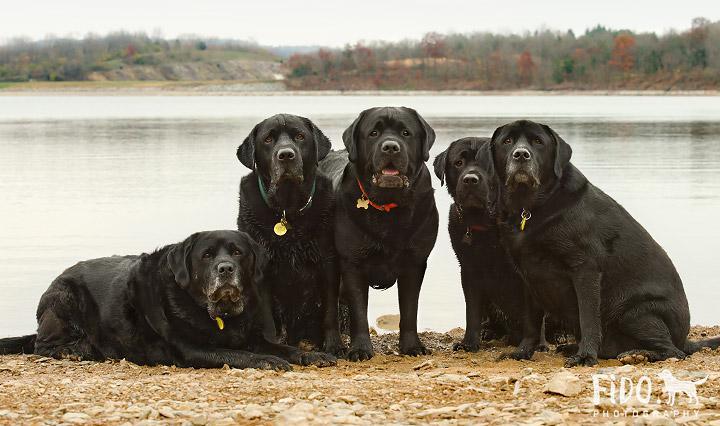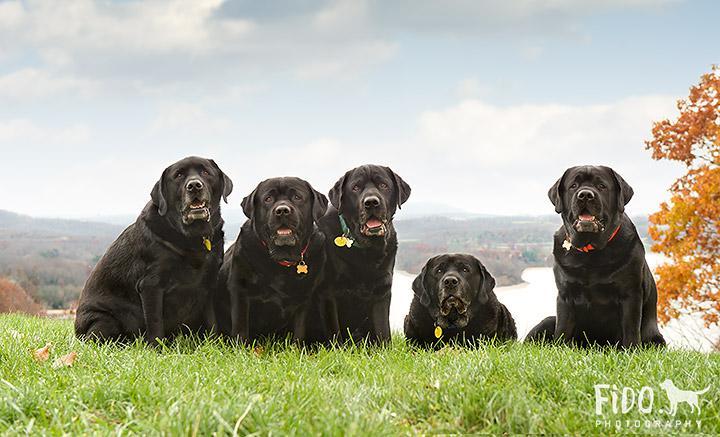The first image is the image on the left, the second image is the image on the right. Analyze the images presented: Is the assertion "The right image contains at least three dogs." valid? Answer yes or no. Yes. The first image is the image on the left, the second image is the image on the right. For the images displayed, is the sentence "One image includes exactly two dogs of different colors, and the other features a single dog." factually correct? Answer yes or no. No. 